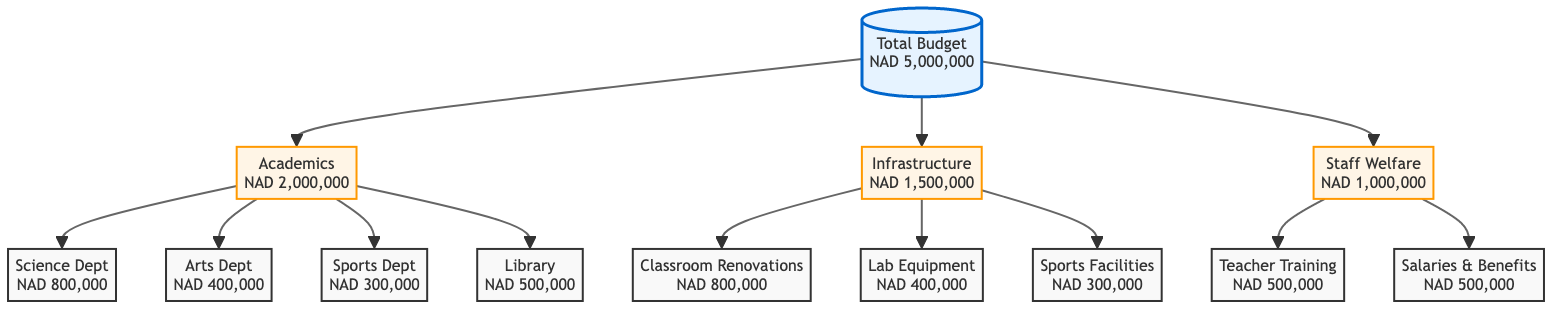What is the total budget for Nuuyoma Senior Secondary School? The diagram specifies that the total budget is represented at the top node, which states "Total Budget" with a value of "NAD 5,000,000."
Answer: NAD 5,000,000 How much is allocated to the Science Department? Looking at the breakdown under the "Academics" section, the node for "Science Dept" indicates an allocation of "NAD 800,000."
Answer: NAD 800,000 What department receives the least funding? By comparing all the departmental allocations, the "Sports Dept" shows the lowest amount of "NAD 300,000."
Answer: Sports Dept How much funding is allocated for staff welfare? In the diagram, under the "Staff Welfare" category, it shows a total allocation of "NAD 1,000,000" for that section.
Answer: NAD 1,000,000 What percentage of the total budget is allocated to infrastructure? The infrastructure budget is "NAD 1,500,000." To find the percentage, divide by the total budget (NAD 5,000,000) and multiply by 100, yielding 30%.
Answer: 30% How many nodes are dedicated to academic departments? The academic section includes four nodes: Science Dept, Arts Dept, Sports Dept, and Library, totaling four nodes dedicated to departments.
Answer: 4 What is the combined budget for Classroom Renovations and Lab Equipment? The allocations for Classroom Renovations and Lab Equipment are "NAD 800,000" and "NAD 400,000," respectively. Adding these two gives "NAD 1,200,000."
Answer: NAD 1,200,000 Which category has the highest allocation after Academics? Infrastructure has the next highest allocation after Academics, with a total of "NAD 1,500,000."
Answer: Infrastructure What is the total budget allocated for teacher training and salaries & benefits? The teacher training allocation is "NAD 500,000" and salaries & benefits also amount to "NAD 500,000." Adding these two together results in "NAD 1,000,000."
Answer: NAD 1,000,000 